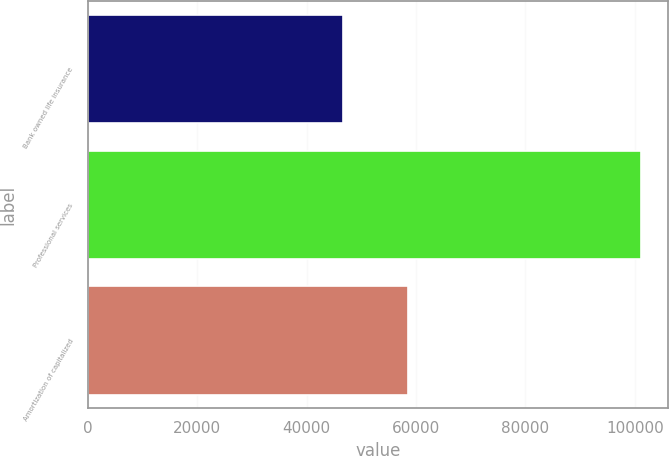Convert chart to OTSL. <chart><loc_0><loc_0><loc_500><loc_500><bar_chart><fcel>Bank owned life insurance<fcel>Professional services<fcel>Amortization of capitalized<nl><fcel>46695<fcel>101096<fcel>58467<nl></chart> 